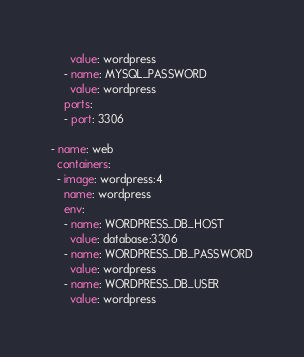Convert code to text. <code><loc_0><loc_0><loc_500><loc_500><_YAML_>      value: wordpress
    - name: MYSQL_PASSWORD
      value: wordpress
    ports:
    - port: 3306

- name: web
  containers:
  - image: wordpress:4
    name: wordpress
    env:
    - name: WORDPRESS_DB_HOST
      value: database:3306
    - name: WORDPRESS_DB_PASSWORD
      value: wordpress
    - name: WORDPRESS_DB_USER
      value: wordpress</code> 